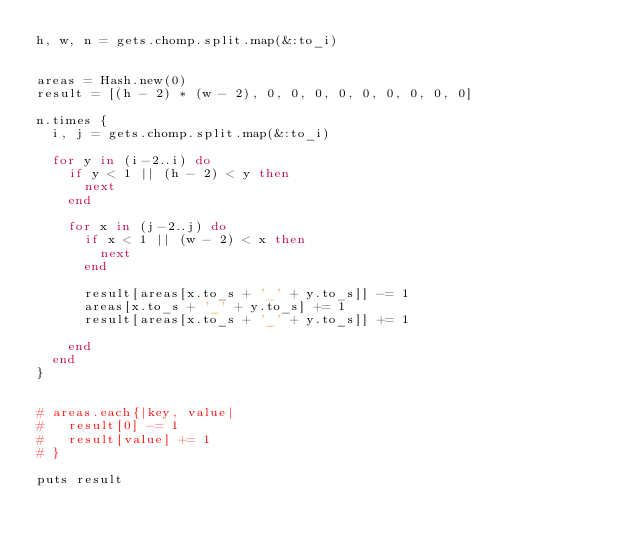Convert code to text. <code><loc_0><loc_0><loc_500><loc_500><_Ruby_>h, w, n = gets.chomp.split.map(&:to_i)


areas = Hash.new(0)
result = [(h - 2) * (w - 2), 0, 0, 0, 0, 0, 0, 0, 0, 0]

n.times {
  i, j = gets.chomp.split.map(&:to_i)

  for y in (i-2..i) do
    if y < 1 || (h - 2) < y then
      next
    end

    for x in (j-2..j) do
      if x < 1 || (w - 2) < x then
        next
      end

      result[areas[x.to_s + '_' + y.to_s]] -= 1
      areas[x.to_s + '_' + y.to_s] += 1
      result[areas[x.to_s + '_' + y.to_s]] += 1

    end
  end
}


# areas.each{|key, value|
#   result[0] -= 1
#   result[value] += 1
# }

puts result
</code> 